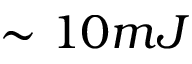<formula> <loc_0><loc_0><loc_500><loc_500>\sim 1 0 m J</formula> 